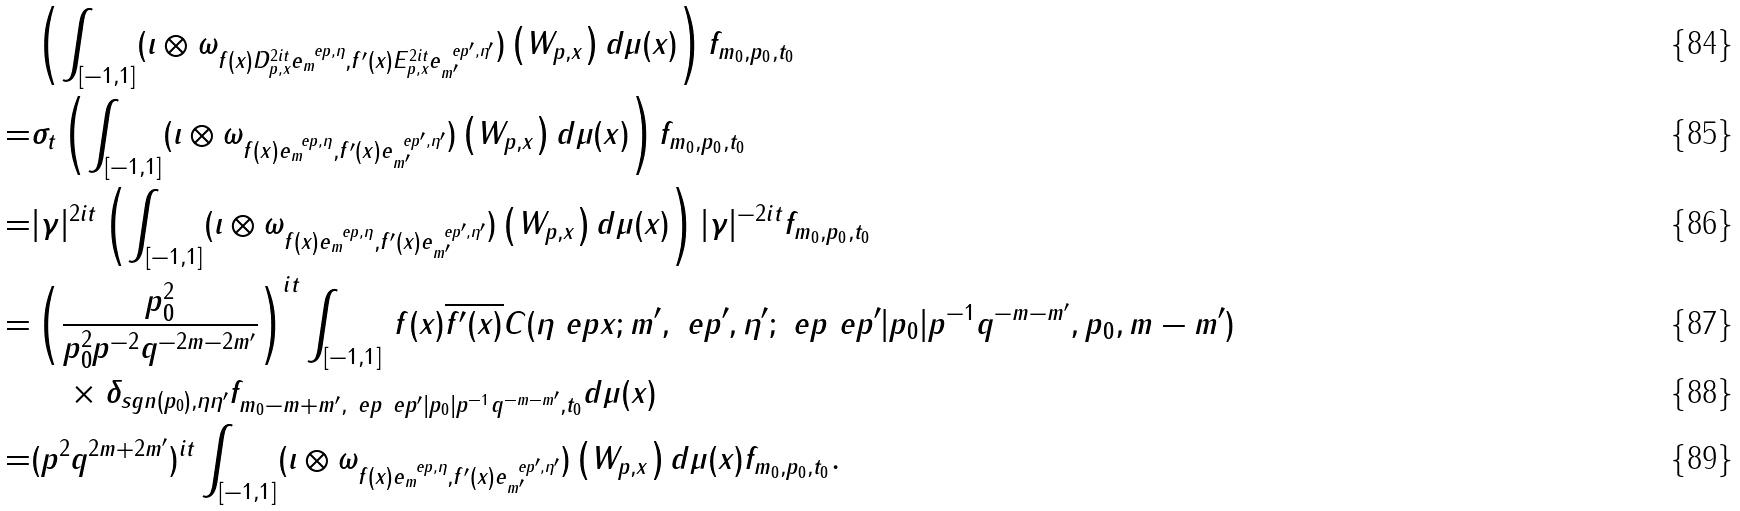Convert formula to latex. <formula><loc_0><loc_0><loc_500><loc_500>& \left ( \int _ { [ - 1 , 1 ] } ( \iota \otimes \omega _ { f ( x ) D _ { p , x } ^ { 2 i t } e ^ { \ e p , \eta } _ { m } , f ^ { \prime } ( x ) E _ { p , x } ^ { 2 i t } e ^ { \ e p ^ { \prime } , \eta ^ { \prime } } _ { m ^ { \prime } } } ) \left ( W _ { p , x } \right ) d \mu ( x ) \right ) f _ { m _ { 0 } , p _ { 0 } , t _ { 0 } } \\ = & \sigma _ { t } \left ( \int _ { [ - 1 , 1 ] } ( \iota \otimes \omega _ { f ( x ) e ^ { \ e p , \eta } _ { m } , f ^ { \prime } ( x ) e ^ { \ e p ^ { \prime } , \eta ^ { \prime } } _ { m ^ { \prime } } } ) \left ( W _ { p , x } \right ) d \mu ( x ) \right ) f _ { m _ { 0 } , p _ { 0 } , t _ { 0 } } \\ = & | \gamma | ^ { 2 i t } \left ( \int _ { [ - 1 , 1 ] } ( \iota \otimes \omega _ { f ( x ) e ^ { \ e p , \eta } _ { m } , f ^ { \prime } ( x ) e ^ { \ e p ^ { \prime } , \eta ^ { \prime } } _ { m ^ { \prime } } } ) \left ( W _ { p , x } \right ) d \mu ( x ) \right ) | \gamma | ^ { - 2 i t } f _ { m _ { 0 } , p _ { 0 } , t _ { 0 } } \\ = & \left ( \frac { p _ { 0 } ^ { 2 } } { p _ { 0 } ^ { 2 } p ^ { - 2 } q ^ { - 2 m - 2 m ^ { \prime } } } \right ) ^ { i t } \int _ { [ - 1 , 1 ] } \, f ( x ) \overline { f ^ { \prime } ( x ) } C ( \eta \ e p x ; m ^ { \prime } , \ e p ^ { \prime } , \eta ^ { \prime } ; \ e p \ e p ^ { \prime } | p _ { 0 } | p ^ { - 1 } q ^ { - m - m ^ { \prime } } , p _ { 0 } , m - m ^ { \prime } ) \\ & \quad \times \delta _ { s g n ( p _ { 0 } ) , \eta \eta ^ { \prime } } f _ { m _ { 0 } - m + m ^ { \prime } , \ e p \ e p ^ { \prime } | p _ { 0 } | p ^ { - 1 } q ^ { - m - m ^ { \prime } } , t _ { 0 } } d \mu ( x ) \\ = & ( p ^ { 2 } q ^ { 2 m + 2 m ^ { \prime } } ) ^ { i t } \int _ { [ - 1 , 1 ] } ( \iota \otimes \omega _ { f ( x ) e ^ { \ e p , \eta } _ { m } , f ^ { \prime } ( x ) e ^ { \ e p ^ { \prime } , \eta ^ { \prime } } _ { m ^ { \prime } } } ) \left ( W _ { p , x } \right ) d \mu ( x ) f _ { m _ { 0 } , p _ { 0 } , t _ { 0 } } .</formula> 